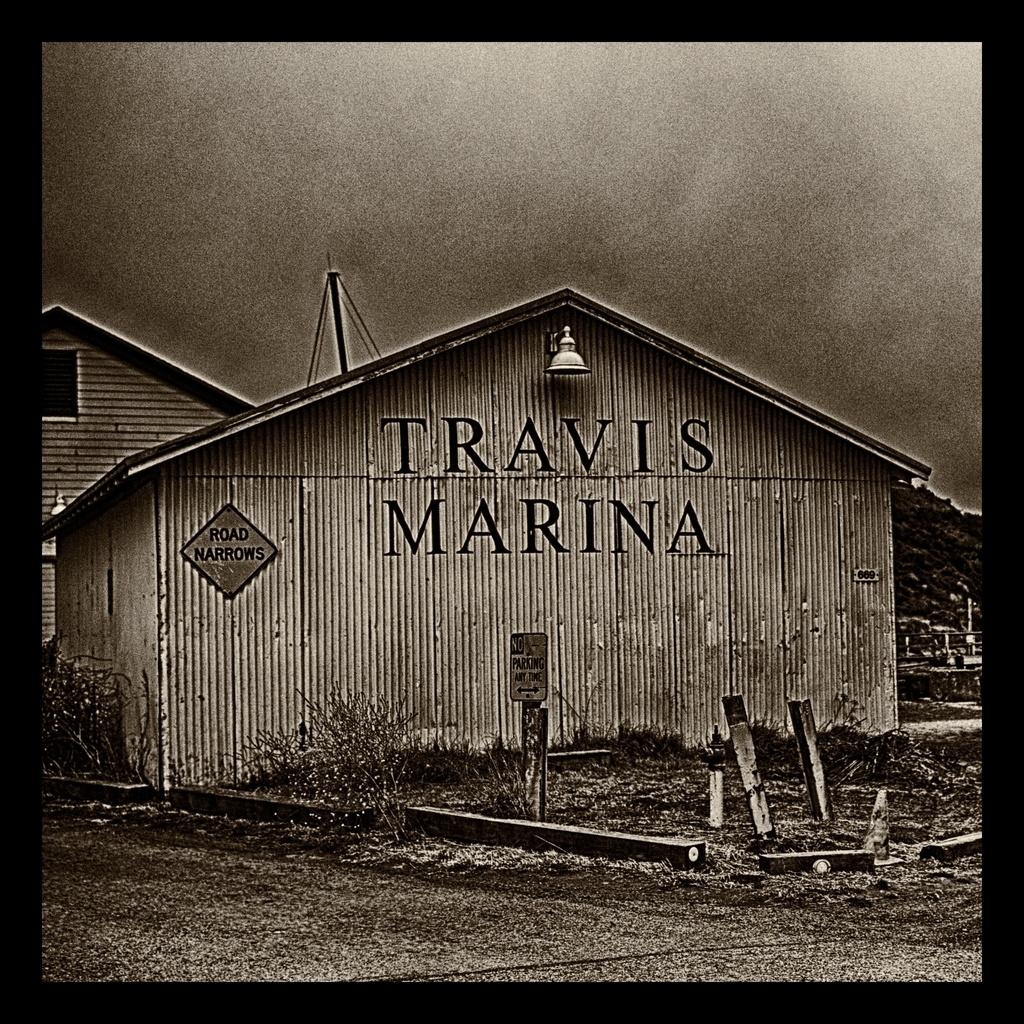What type of pathway is visible in the image? There is a road in the image. What objects can be seen in the image besides the road? There are boards, plants, a wooden house, and trees visible in the image. Can you describe the structure in the image? There is a wooden house in the image. What type of vegetation is present in the image? There are plants and trees in the image. What is visible in the background of the image? The sky is visible in the background of the image. What is the price of the fifth dog in the image? There are no dogs present in the image, and the concept of a "fifth dog" is not applicable. 